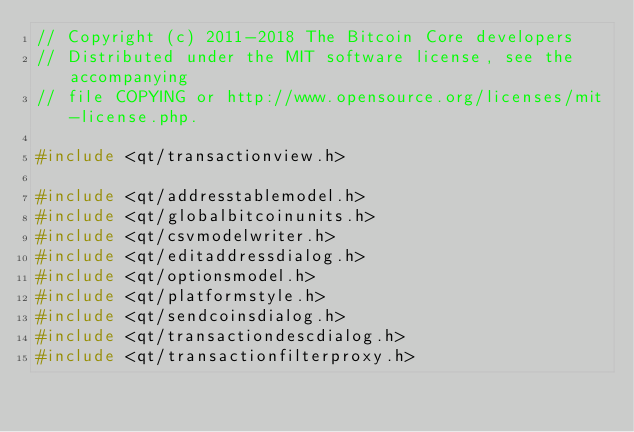<code> <loc_0><loc_0><loc_500><loc_500><_C++_>// Copyright (c) 2011-2018 The Bitcoin Core developers
// Distributed under the MIT software license, see the accompanying
// file COPYING or http://www.opensource.org/licenses/mit-license.php.

#include <qt/transactionview.h>

#include <qt/addresstablemodel.h>
#include <qt/globalbitcoinunits.h>
#include <qt/csvmodelwriter.h>
#include <qt/editaddressdialog.h>
#include <qt/optionsmodel.h>
#include <qt/platformstyle.h>
#include <qt/sendcoinsdialog.h>
#include <qt/transactiondescdialog.h>
#include <qt/transactionfilterproxy.h></code> 